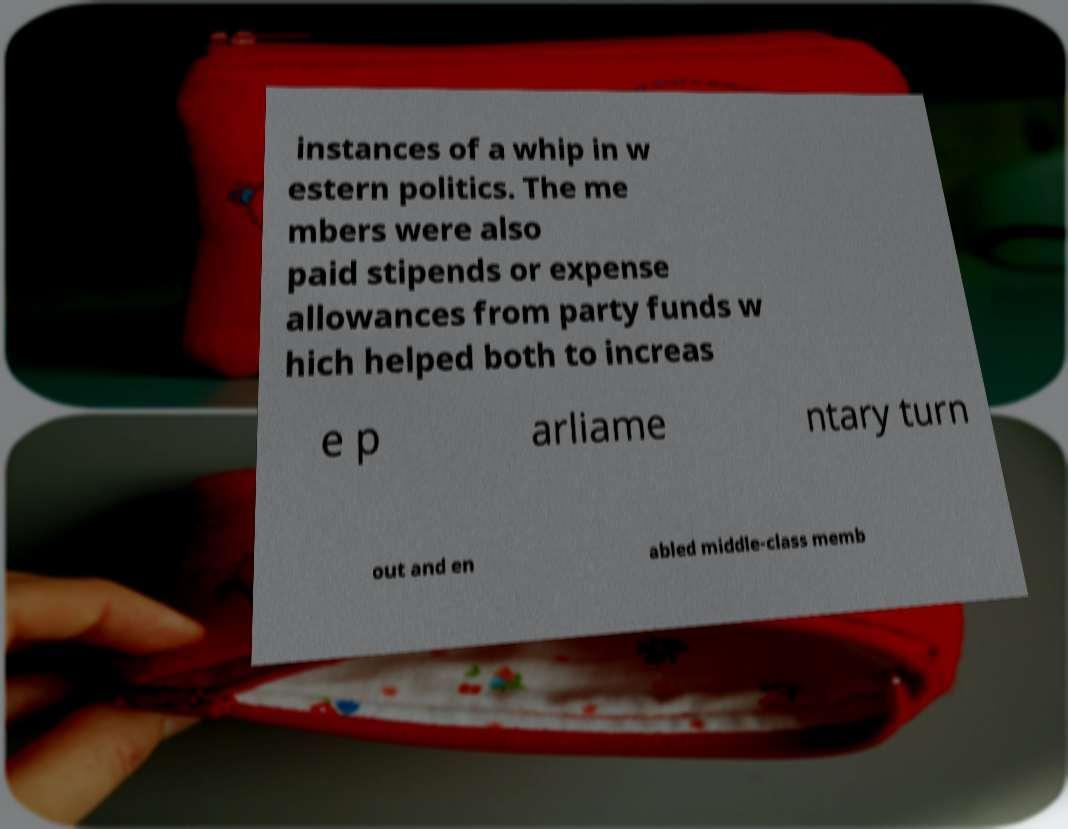For documentation purposes, I need the text within this image transcribed. Could you provide that? instances of a whip in w estern politics. The me mbers were also paid stipends or expense allowances from party funds w hich helped both to increas e p arliame ntary turn out and en abled middle-class memb 